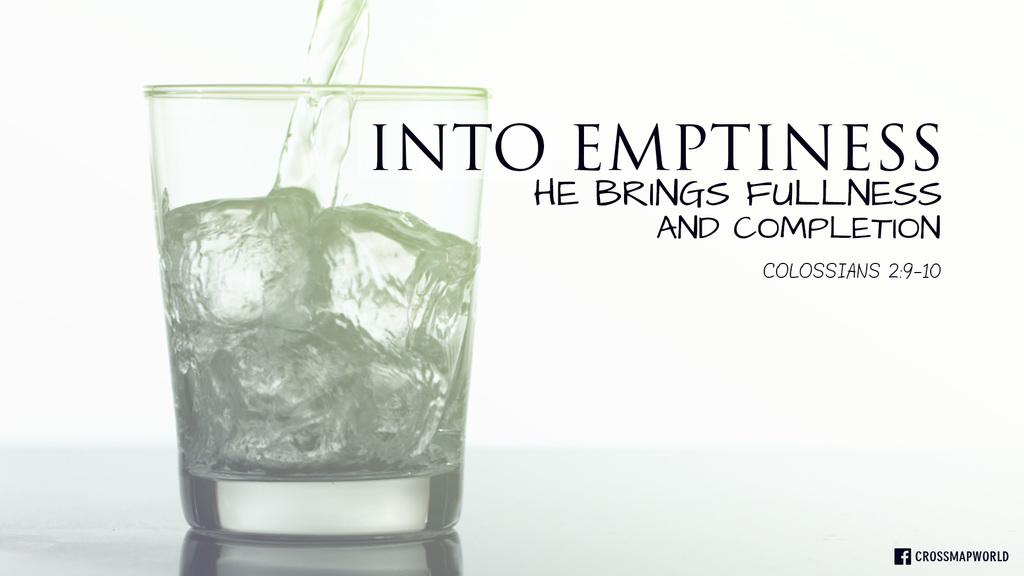<image>
Create a compact narrative representing the image presented. Ad for alcohol that talks about Bringing fullness and competion. 